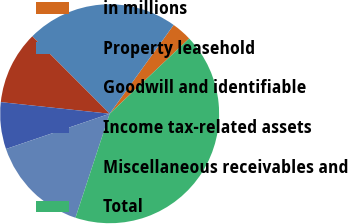Convert chart. <chart><loc_0><loc_0><loc_500><loc_500><pie_chart><fcel>in millions<fcel>Property leasehold<fcel>Goodwill and identifiable<fcel>Income tax-related assets<fcel>Miscellaneous receivables and<fcel>Total<nl><fcel>3.0%<fcel>22.43%<fcel>10.82%<fcel>6.91%<fcel>14.73%<fcel>42.12%<nl></chart> 